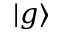Convert formula to latex. <formula><loc_0><loc_0><loc_500><loc_500>| g \rangle</formula> 